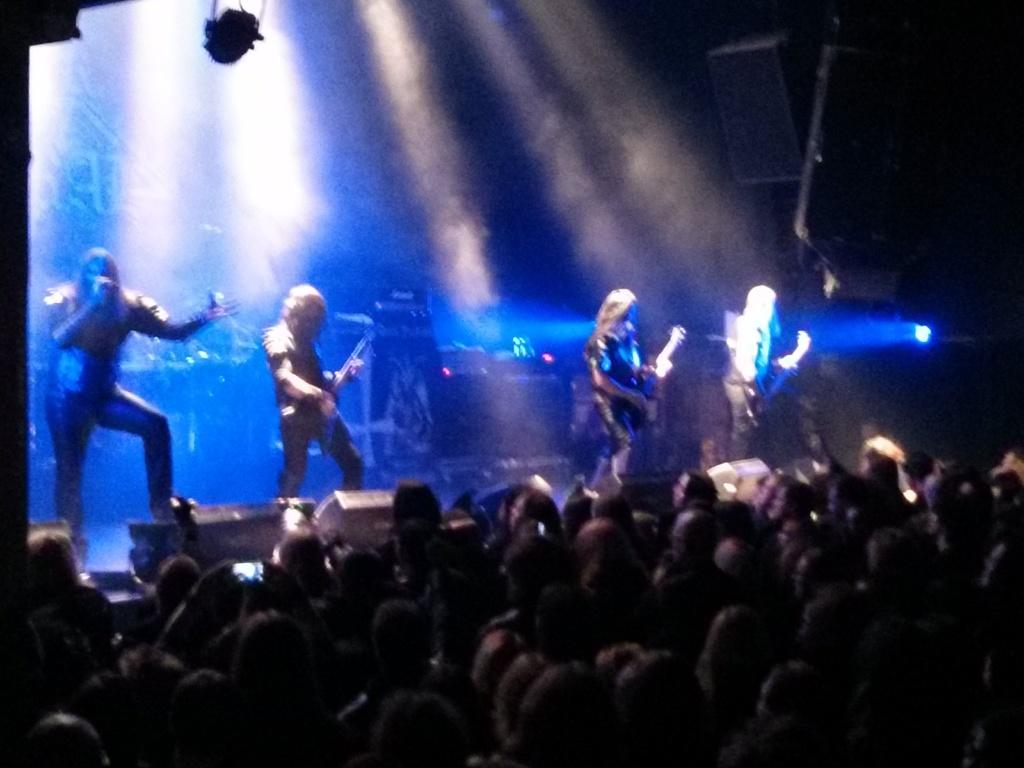What is happening at the top of the image? There are persons on a dais at the top of the image. What are the persons on the dais doing? The persons on the dais are holding musical instruments. What can be seen at the bottom of the image? There is a crowd standing at the bottom of the image. What is the observation made by the toe of the person on the dais? There is no mention of a toe making an observation in the image, as the focus is on the persons holding musical instruments on the dais and the crowd at the bottom of the image. 